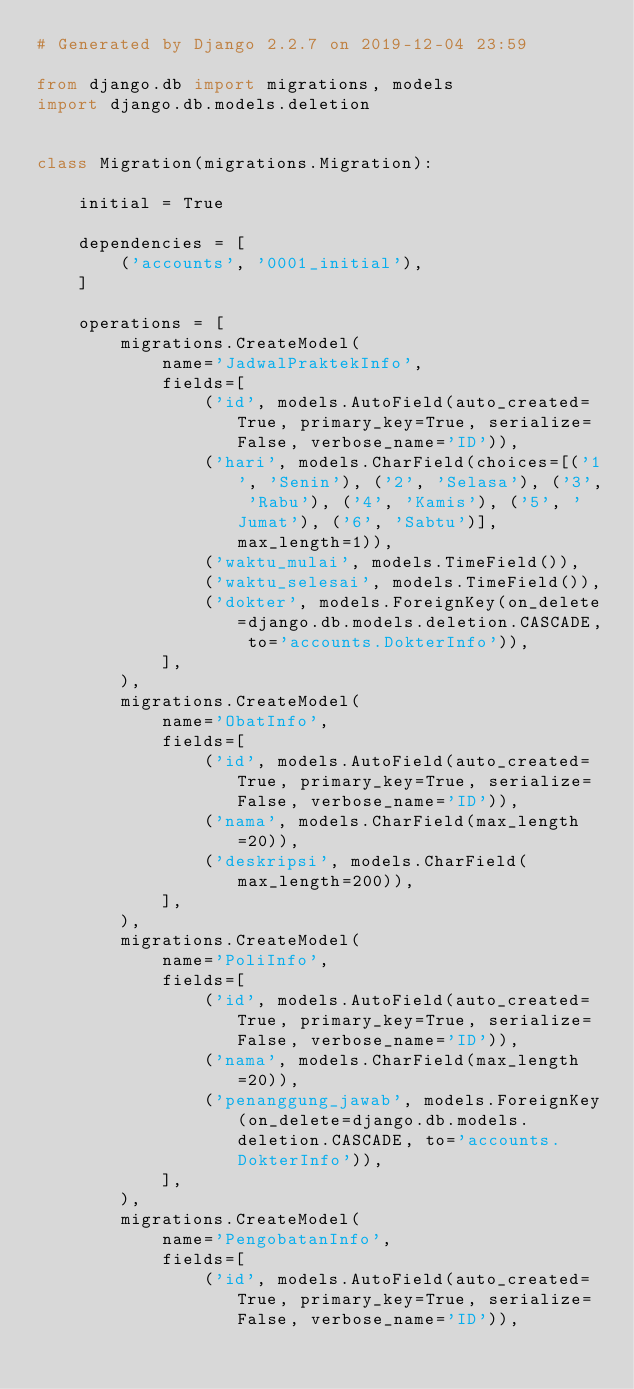Convert code to text. <code><loc_0><loc_0><loc_500><loc_500><_Python_># Generated by Django 2.2.7 on 2019-12-04 23:59

from django.db import migrations, models
import django.db.models.deletion


class Migration(migrations.Migration):

    initial = True

    dependencies = [
        ('accounts', '0001_initial'),
    ]

    operations = [
        migrations.CreateModel(
            name='JadwalPraktekInfo',
            fields=[
                ('id', models.AutoField(auto_created=True, primary_key=True, serialize=False, verbose_name='ID')),
                ('hari', models.CharField(choices=[('1', 'Senin'), ('2', 'Selasa'), ('3', 'Rabu'), ('4', 'Kamis'), ('5', 'Jumat'), ('6', 'Sabtu')], max_length=1)),
                ('waktu_mulai', models.TimeField()),
                ('waktu_selesai', models.TimeField()),
                ('dokter', models.ForeignKey(on_delete=django.db.models.deletion.CASCADE, to='accounts.DokterInfo')),
            ],
        ),
        migrations.CreateModel(
            name='ObatInfo',
            fields=[
                ('id', models.AutoField(auto_created=True, primary_key=True, serialize=False, verbose_name='ID')),
                ('nama', models.CharField(max_length=20)),
                ('deskripsi', models.CharField(max_length=200)),
            ],
        ),
        migrations.CreateModel(
            name='PoliInfo',
            fields=[
                ('id', models.AutoField(auto_created=True, primary_key=True, serialize=False, verbose_name='ID')),
                ('nama', models.CharField(max_length=20)),
                ('penanggung_jawab', models.ForeignKey(on_delete=django.db.models.deletion.CASCADE, to='accounts.DokterInfo')),
            ],
        ),
        migrations.CreateModel(
            name='PengobatanInfo',
            fields=[
                ('id', models.AutoField(auto_created=True, primary_key=True, serialize=False, verbose_name='ID')),</code> 